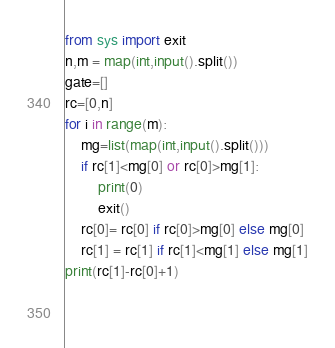<code> <loc_0><loc_0><loc_500><loc_500><_Python_>from sys import exit
n,m = map(int,input().split())
gate=[]
rc=[0,n]
for i in range(m):
    mg=list(map(int,input().split()))
    if rc[1]<mg[0] or rc[0]>mg[1]:
        print(0)
        exit()
    rc[0]= rc[0] if rc[0]>mg[0] else mg[0]
    rc[1] = rc[1] if rc[1]<mg[1] else mg[1]
print(rc[1]-rc[0]+1)

        
</code> 